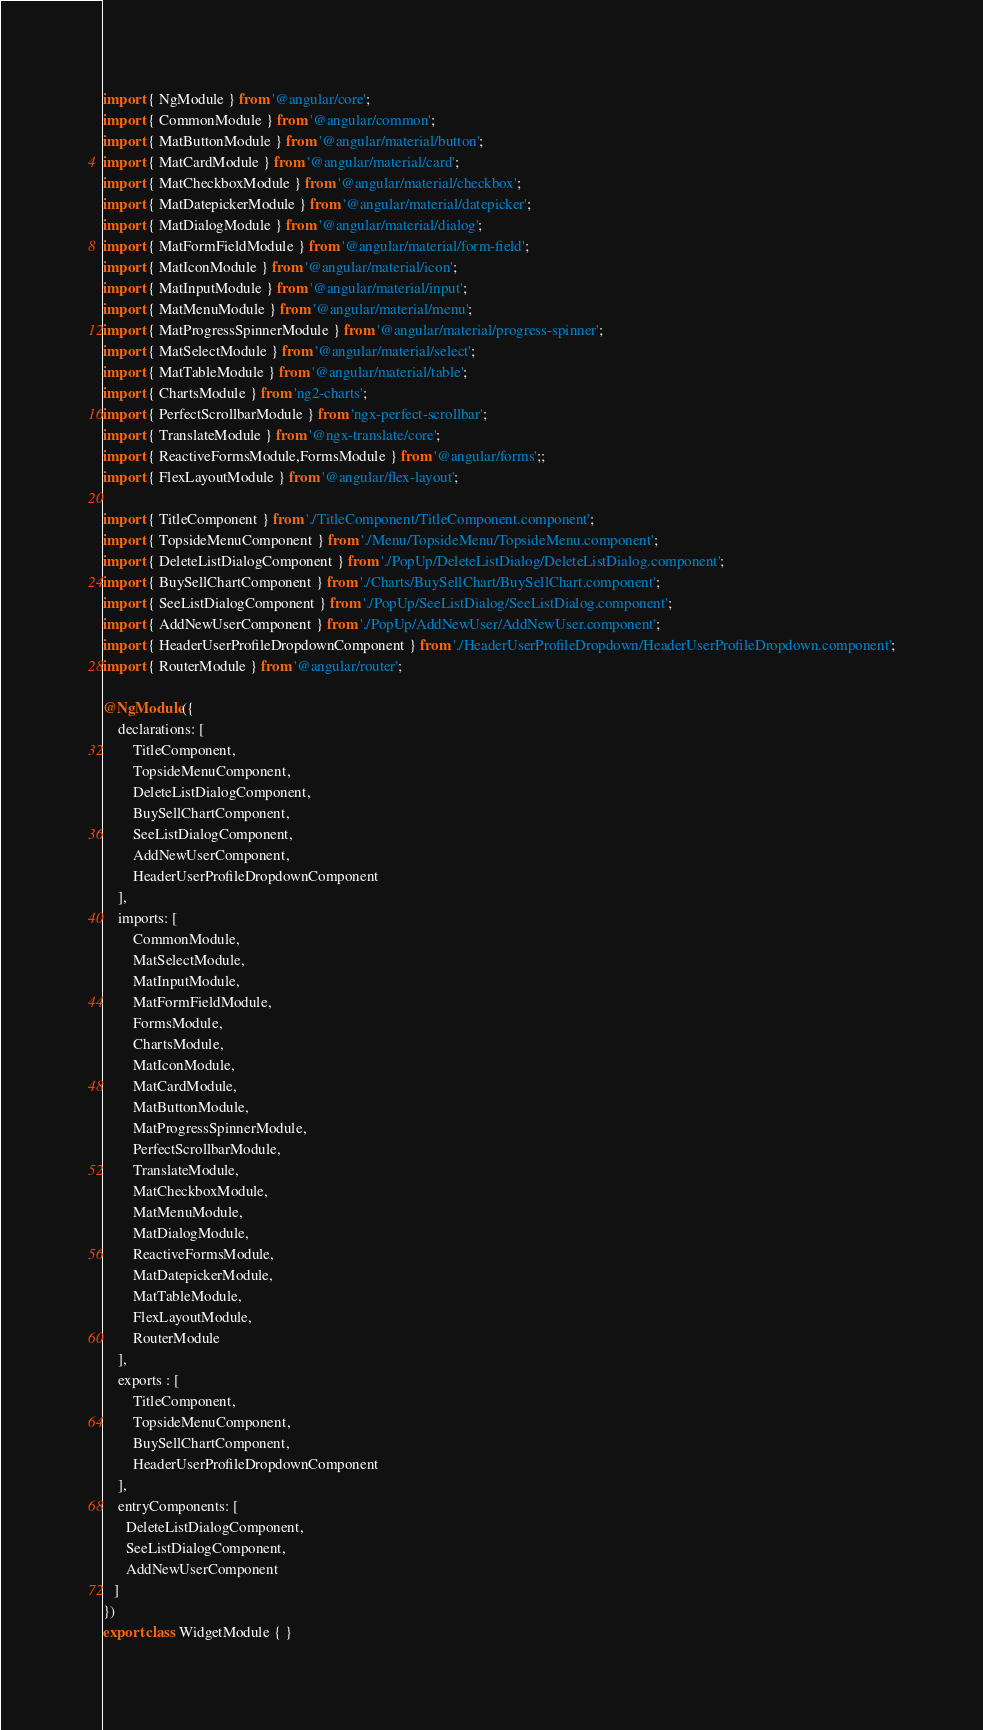<code> <loc_0><loc_0><loc_500><loc_500><_TypeScript_>import { NgModule } from '@angular/core';
import { CommonModule } from '@angular/common';
import { MatButtonModule } from '@angular/material/button';
import { MatCardModule } from '@angular/material/card';
import { MatCheckboxModule } from '@angular/material/checkbox';
import { MatDatepickerModule } from '@angular/material/datepicker';
import { MatDialogModule } from '@angular/material/dialog';
import { MatFormFieldModule } from '@angular/material/form-field';
import { MatIconModule } from '@angular/material/icon';
import { MatInputModule } from '@angular/material/input';
import { MatMenuModule } from '@angular/material/menu';
import { MatProgressSpinnerModule } from '@angular/material/progress-spinner';
import { MatSelectModule } from '@angular/material/select';
import { MatTableModule } from '@angular/material/table';
import { ChartsModule } from 'ng2-charts';
import { PerfectScrollbarModule } from 'ngx-perfect-scrollbar';
import { TranslateModule } from '@ngx-translate/core';
import { ReactiveFormsModule,FormsModule } from '@angular/forms';;
import { FlexLayoutModule } from '@angular/flex-layout';

import { TitleComponent } from './TitleComponent/TitleComponent.component';
import { TopsideMenuComponent } from './Menu/TopsideMenu/TopsideMenu.component';
import { DeleteListDialogComponent } from './PopUp/DeleteListDialog/DeleteListDialog.component';
import { BuySellChartComponent } from './Charts/BuySellChart/BuySellChart.component';
import { SeeListDialogComponent } from './PopUp/SeeListDialog/SeeListDialog.component';
import { AddNewUserComponent } from './PopUp/AddNewUser/AddNewUser.component';
import { HeaderUserProfileDropdownComponent } from './HeaderUserProfileDropdown/HeaderUserProfileDropdown.component';
import { RouterModule } from '@angular/router';

@NgModule({
	declarations: [
		TitleComponent,
		TopsideMenuComponent,
		DeleteListDialogComponent,
		BuySellChartComponent,
		SeeListDialogComponent,
		AddNewUserComponent,
		HeaderUserProfileDropdownComponent
	],
	imports: [
		CommonModule,
		MatSelectModule,
		MatInputModule,
		MatFormFieldModule,
		FormsModule,
		ChartsModule,
		MatIconModule,
		MatCardModule,
		MatButtonModule,
		MatProgressSpinnerModule,
		PerfectScrollbarModule,
		TranslateModule,
		MatCheckboxModule,
		MatMenuModule,
		MatDialogModule,
		ReactiveFormsModule,
		MatDatepickerModule,
		MatTableModule,  
		FlexLayoutModule,
		RouterModule
	],
	exports : [
		TitleComponent,
		TopsideMenuComponent,
		BuySellChartComponent,
		HeaderUserProfileDropdownComponent
	],
	entryComponents: [
      DeleteListDialogComponent,
      SeeListDialogComponent,
      AddNewUserComponent
   ]
})
export class WidgetModule { }
</code> 